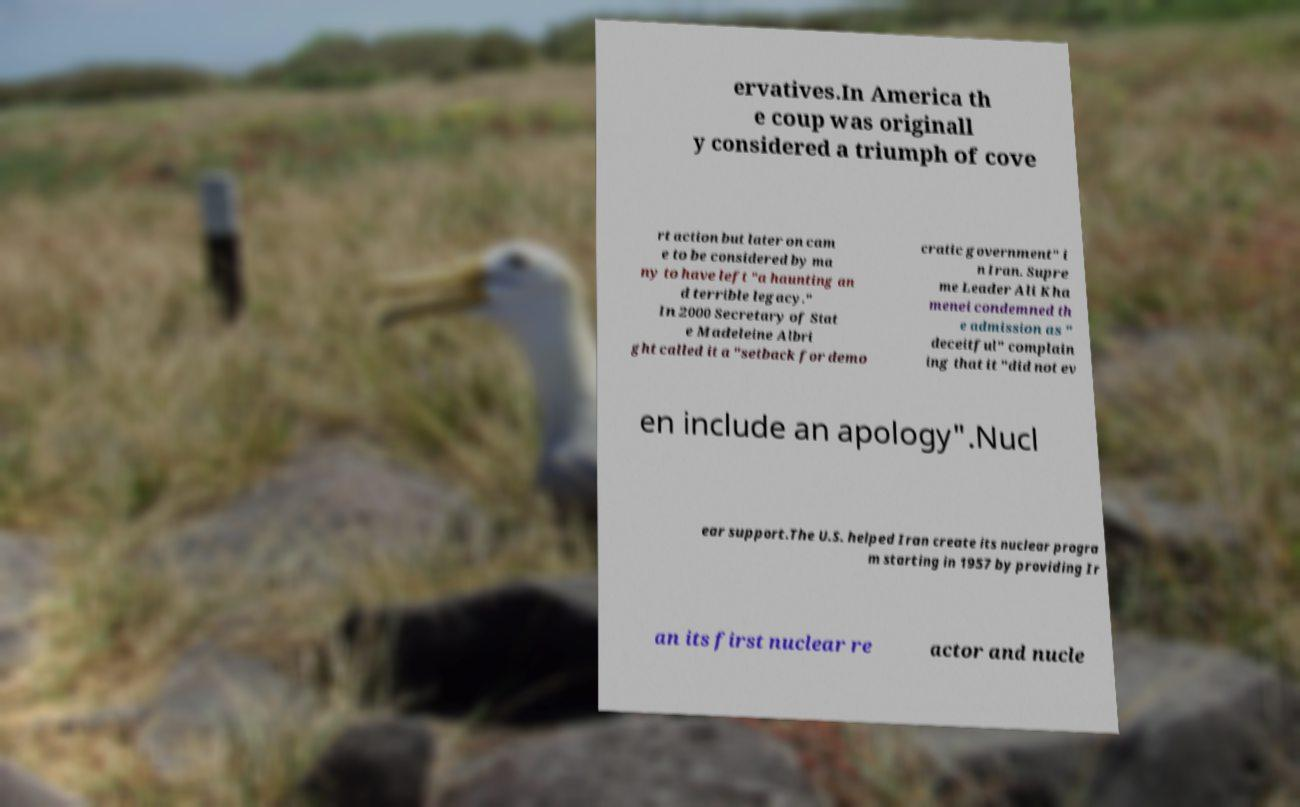Please identify and transcribe the text found in this image. ervatives.In America th e coup was originall y considered a triumph of cove rt action but later on cam e to be considered by ma ny to have left "a haunting an d terrible legacy." In 2000 Secretary of Stat e Madeleine Albri ght called it a "setback for demo cratic government" i n Iran. Supre me Leader Ali Kha menei condemned th e admission as " deceitful" complain ing that it "did not ev en include an apology".Nucl ear support.The U.S. helped Iran create its nuclear progra m starting in 1957 by providing Ir an its first nuclear re actor and nucle 